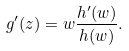Convert formula to latex. <formula><loc_0><loc_0><loc_500><loc_500>g ^ { \prime } ( z ) = w \frac { h ^ { \prime } ( w ) } { h ( w ) } .</formula> 